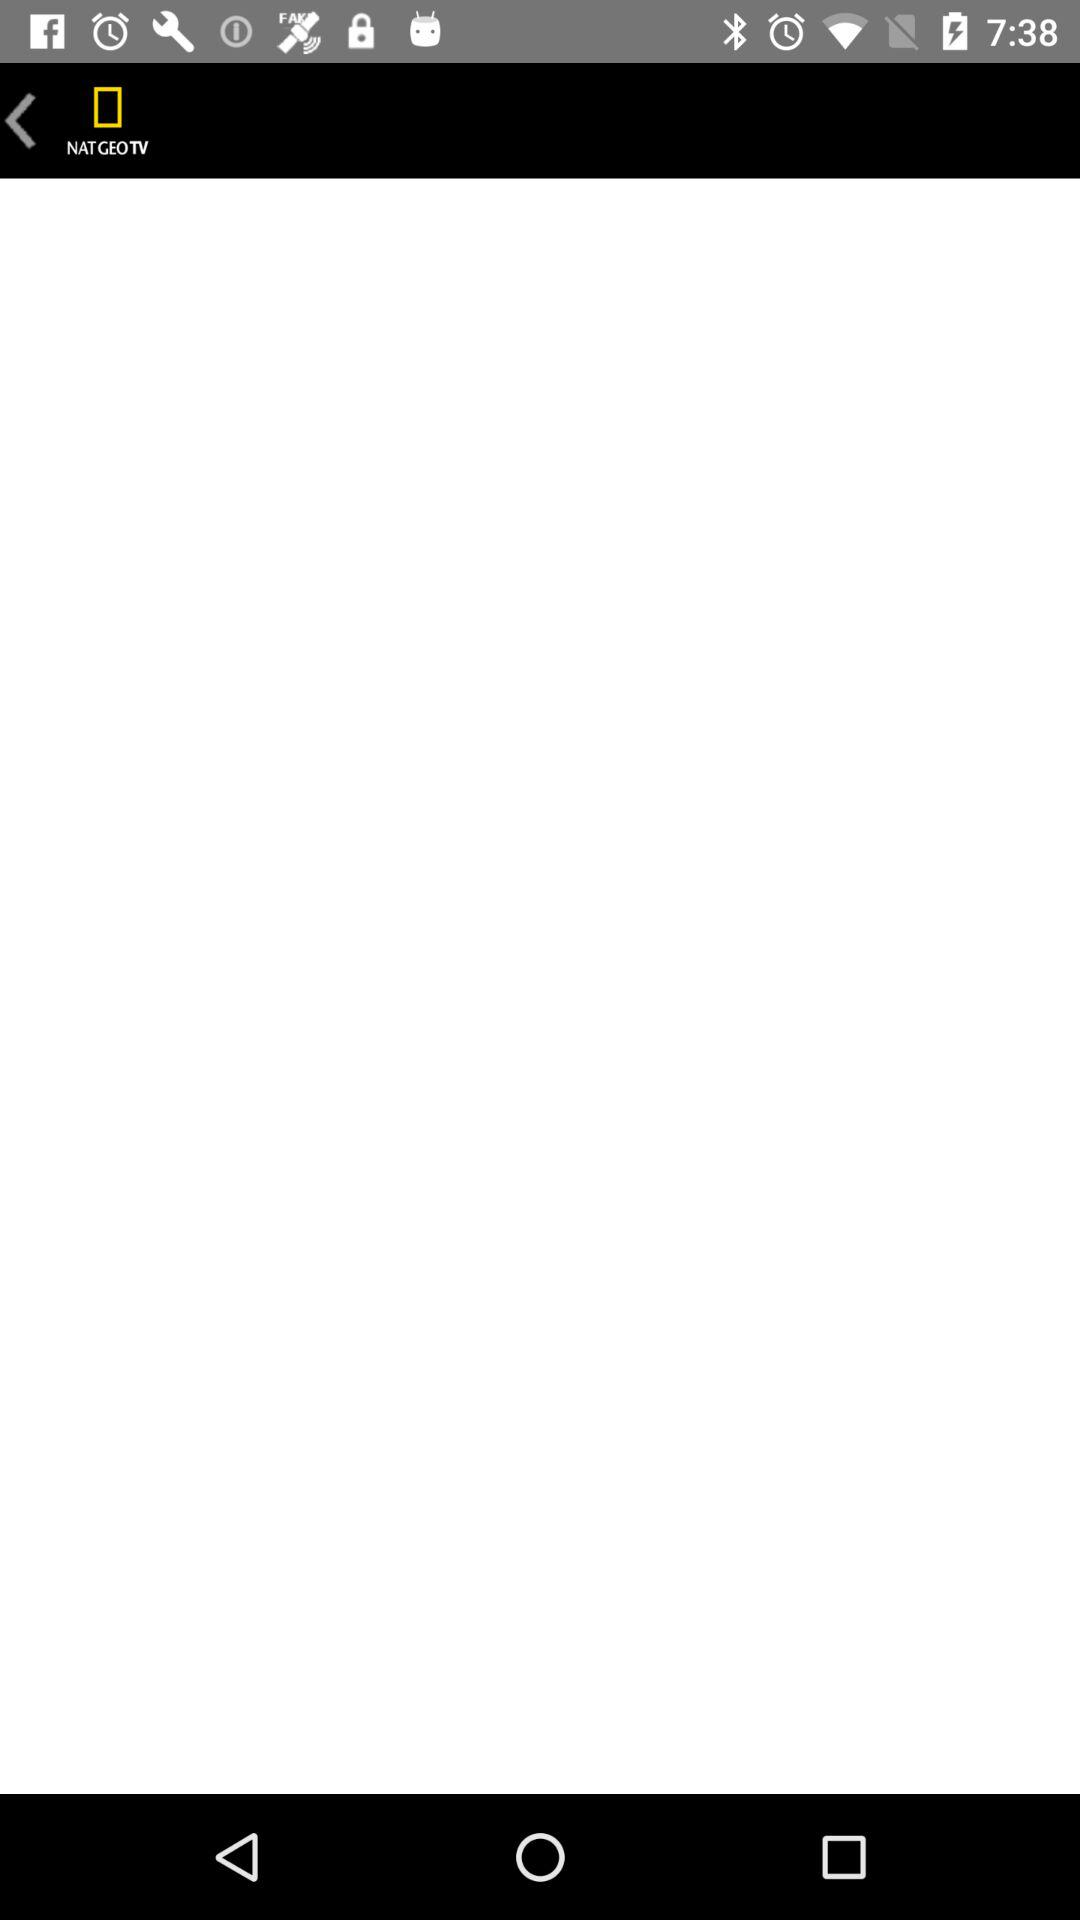What is the name of the application? The name of the application is "NAT GEO TV". 